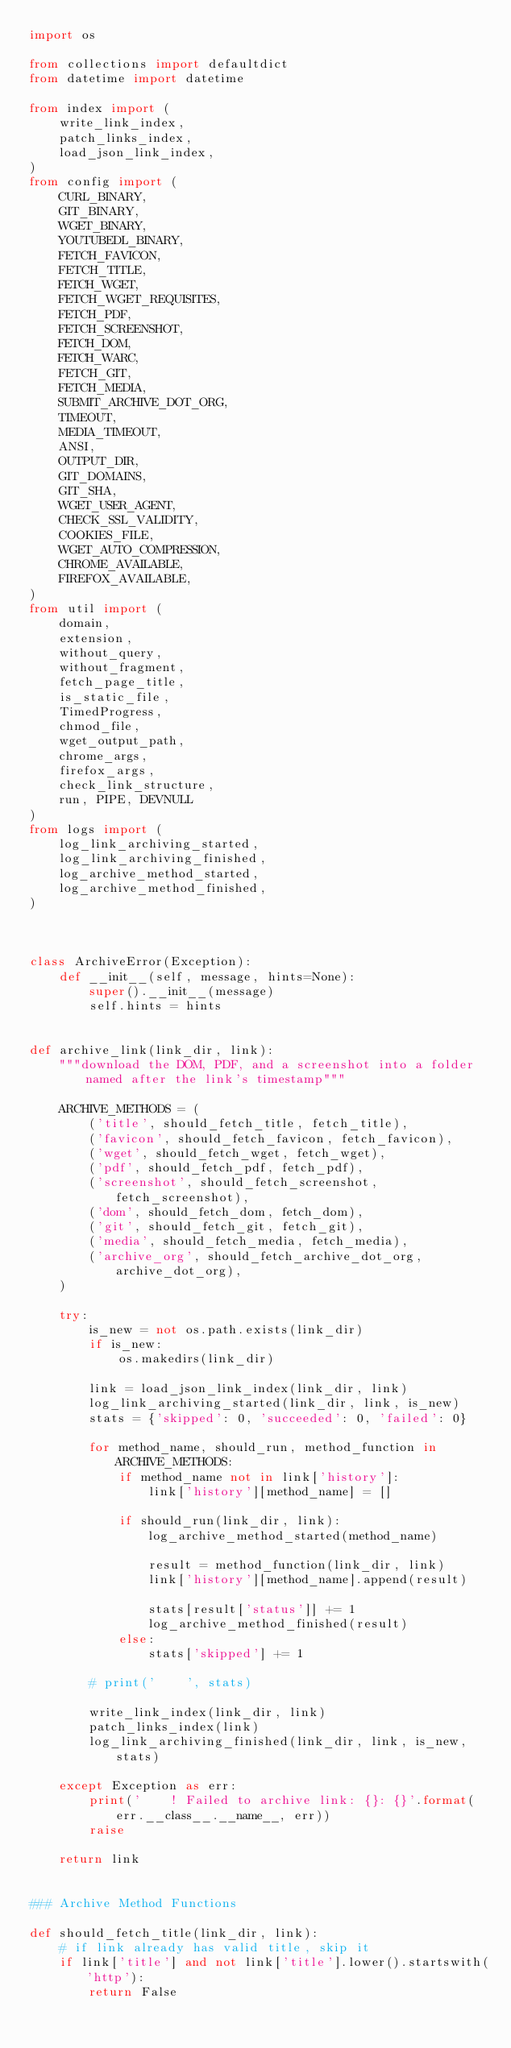Convert code to text. <code><loc_0><loc_0><loc_500><loc_500><_Python_>import os

from collections import defaultdict
from datetime import datetime

from index import (
    write_link_index,
    patch_links_index,
    load_json_link_index,
)
from config import (
    CURL_BINARY,
    GIT_BINARY,
    WGET_BINARY,
    YOUTUBEDL_BINARY,
    FETCH_FAVICON,
    FETCH_TITLE,
    FETCH_WGET,
    FETCH_WGET_REQUISITES,
    FETCH_PDF,
    FETCH_SCREENSHOT,
    FETCH_DOM,
    FETCH_WARC,
    FETCH_GIT,
    FETCH_MEDIA,
    SUBMIT_ARCHIVE_DOT_ORG,
    TIMEOUT,
    MEDIA_TIMEOUT,
    ANSI,
    OUTPUT_DIR,
    GIT_DOMAINS,
    GIT_SHA,
    WGET_USER_AGENT,
    CHECK_SSL_VALIDITY,
    COOKIES_FILE,
    WGET_AUTO_COMPRESSION,
    CHROME_AVAILABLE,
    FIREFOX_AVAILABLE,
)
from util import (
    domain,
    extension,
    without_query,
    without_fragment,
    fetch_page_title,
    is_static_file,
    TimedProgress,
    chmod_file,
    wget_output_path,
    chrome_args,
    firefox_args,
    check_link_structure,
    run, PIPE, DEVNULL
)
from logs import (
    log_link_archiving_started,
    log_link_archiving_finished,
    log_archive_method_started,
    log_archive_method_finished,
)



class ArchiveError(Exception):
    def __init__(self, message, hints=None):
        super().__init__(message)
        self.hints = hints


def archive_link(link_dir, link):
    """download the DOM, PDF, and a screenshot into a folder named after the link's timestamp"""

    ARCHIVE_METHODS = (
        ('title', should_fetch_title, fetch_title),
        ('favicon', should_fetch_favicon, fetch_favicon),
        ('wget', should_fetch_wget, fetch_wget),
        ('pdf', should_fetch_pdf, fetch_pdf),
        ('screenshot', should_fetch_screenshot, fetch_screenshot),
        ('dom', should_fetch_dom, fetch_dom),
        ('git', should_fetch_git, fetch_git),
        ('media', should_fetch_media, fetch_media),
        ('archive_org', should_fetch_archive_dot_org, archive_dot_org),
    )
    
    try:
        is_new = not os.path.exists(link_dir)
        if is_new:
            os.makedirs(link_dir)

        link = load_json_link_index(link_dir, link)
        log_link_archiving_started(link_dir, link, is_new)
        stats = {'skipped': 0, 'succeeded': 0, 'failed': 0}

        for method_name, should_run, method_function in ARCHIVE_METHODS:
            if method_name not in link['history']:
                link['history'][method_name] = []
            
            if should_run(link_dir, link):
                log_archive_method_started(method_name)

                result = method_function(link_dir, link)
                link['history'][method_name].append(result)

                stats[result['status']] += 1
                log_archive_method_finished(result)
            else:
                stats['skipped'] += 1

        # print('    ', stats)

        write_link_index(link_dir, link)
        patch_links_index(link)
        log_link_archiving_finished(link_dir, link, is_new, stats)

    except Exception as err:
        print('    ! Failed to archive link: {}: {}'.format(err.__class__.__name__, err))
        raise
    
    return link


### Archive Method Functions

def should_fetch_title(link_dir, link):
    # if link already has valid title, skip it
    if link['title'] and not link['title'].lower().startswith('http'):
        return False
</code> 